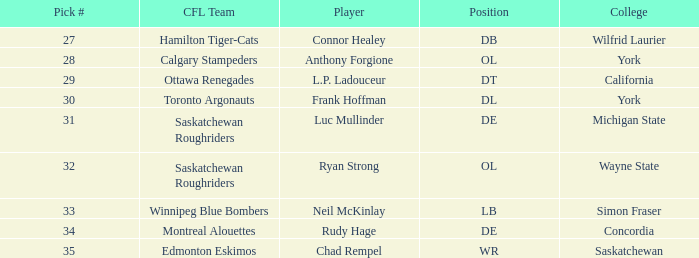What is the Pick # for the Edmonton Eskimos? 1.0. 